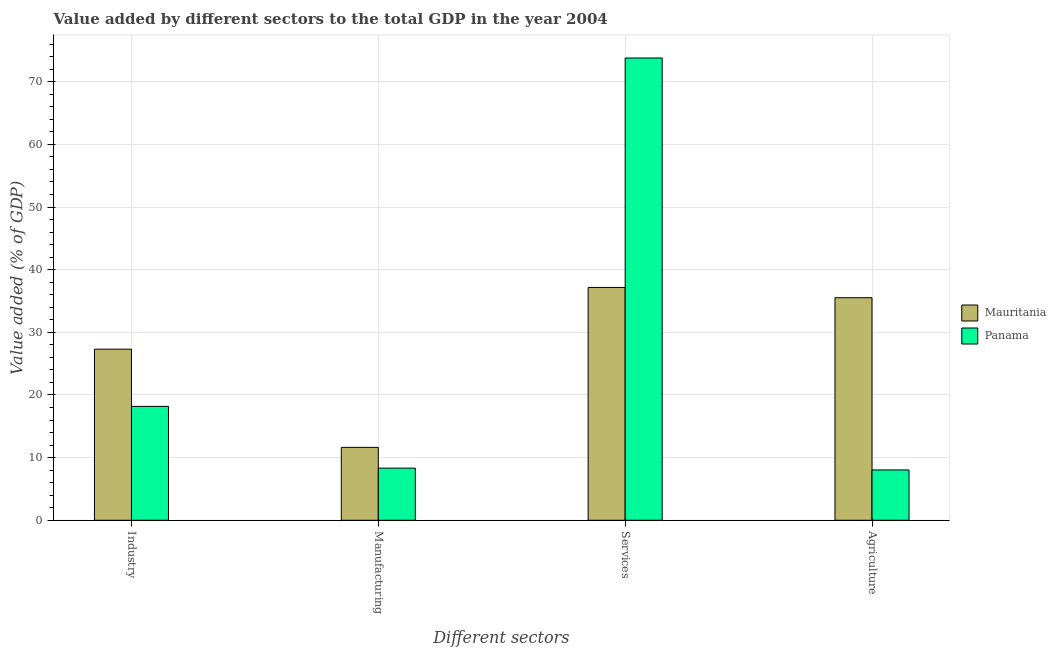How many different coloured bars are there?
Ensure brevity in your answer.  2. Are the number of bars on each tick of the X-axis equal?
Offer a very short reply. Yes. How many bars are there on the 1st tick from the left?
Offer a terse response. 2. What is the label of the 1st group of bars from the left?
Offer a terse response. Industry. What is the value added by services sector in Mauritania?
Your answer should be very brief. 37.16. Across all countries, what is the maximum value added by industrial sector?
Provide a succinct answer. 27.31. Across all countries, what is the minimum value added by agricultural sector?
Give a very brief answer. 8.03. In which country was the value added by services sector maximum?
Keep it short and to the point. Panama. In which country was the value added by manufacturing sector minimum?
Offer a very short reply. Panama. What is the total value added by agricultural sector in the graph?
Make the answer very short. 43.56. What is the difference between the value added by manufacturing sector in Panama and that in Mauritania?
Your response must be concise. -3.31. What is the difference between the value added by services sector in Panama and the value added by agricultural sector in Mauritania?
Your answer should be compact. 38.26. What is the average value added by services sector per country?
Keep it short and to the point. 55.48. What is the difference between the value added by services sector and value added by industrial sector in Mauritania?
Provide a short and direct response. 9.85. In how many countries, is the value added by agricultural sector greater than 38 %?
Offer a terse response. 0. What is the ratio of the value added by manufacturing sector in Panama to that in Mauritania?
Make the answer very short. 0.72. Is the value added by agricultural sector in Panama less than that in Mauritania?
Make the answer very short. Yes. What is the difference between the highest and the second highest value added by agricultural sector?
Ensure brevity in your answer.  27.49. What is the difference between the highest and the lowest value added by manufacturing sector?
Provide a short and direct response. 3.31. In how many countries, is the value added by agricultural sector greater than the average value added by agricultural sector taken over all countries?
Your answer should be very brief. 1. What does the 2nd bar from the left in Manufacturing represents?
Your answer should be very brief. Panama. What does the 1st bar from the right in Industry represents?
Make the answer very short. Panama. How many bars are there?
Ensure brevity in your answer.  8. How many countries are there in the graph?
Keep it short and to the point. 2. Does the graph contain grids?
Your response must be concise. Yes. What is the title of the graph?
Your answer should be very brief. Value added by different sectors to the total GDP in the year 2004. What is the label or title of the X-axis?
Your answer should be very brief. Different sectors. What is the label or title of the Y-axis?
Make the answer very short. Value added (% of GDP). What is the Value added (% of GDP) of Mauritania in Industry?
Keep it short and to the point. 27.31. What is the Value added (% of GDP) of Panama in Industry?
Provide a succinct answer. 18.18. What is the Value added (% of GDP) in Mauritania in Manufacturing?
Give a very brief answer. 11.63. What is the Value added (% of GDP) in Panama in Manufacturing?
Offer a very short reply. 8.32. What is the Value added (% of GDP) of Mauritania in Services?
Keep it short and to the point. 37.16. What is the Value added (% of GDP) in Panama in Services?
Your answer should be compact. 73.79. What is the Value added (% of GDP) of Mauritania in Agriculture?
Make the answer very short. 35.53. What is the Value added (% of GDP) of Panama in Agriculture?
Offer a terse response. 8.03. Across all Different sectors, what is the maximum Value added (% of GDP) in Mauritania?
Keep it short and to the point. 37.16. Across all Different sectors, what is the maximum Value added (% of GDP) in Panama?
Offer a very short reply. 73.79. Across all Different sectors, what is the minimum Value added (% of GDP) in Mauritania?
Keep it short and to the point. 11.63. Across all Different sectors, what is the minimum Value added (% of GDP) in Panama?
Keep it short and to the point. 8.03. What is the total Value added (% of GDP) of Mauritania in the graph?
Give a very brief answer. 111.63. What is the total Value added (% of GDP) of Panama in the graph?
Give a very brief answer. 108.32. What is the difference between the Value added (% of GDP) in Mauritania in Industry and that in Manufacturing?
Ensure brevity in your answer.  15.68. What is the difference between the Value added (% of GDP) in Panama in Industry and that in Manufacturing?
Give a very brief answer. 9.86. What is the difference between the Value added (% of GDP) in Mauritania in Industry and that in Services?
Keep it short and to the point. -9.85. What is the difference between the Value added (% of GDP) in Panama in Industry and that in Services?
Give a very brief answer. -55.61. What is the difference between the Value added (% of GDP) in Mauritania in Industry and that in Agriculture?
Provide a short and direct response. -8.21. What is the difference between the Value added (% of GDP) of Panama in Industry and that in Agriculture?
Your response must be concise. 10.15. What is the difference between the Value added (% of GDP) of Mauritania in Manufacturing and that in Services?
Give a very brief answer. -25.53. What is the difference between the Value added (% of GDP) of Panama in Manufacturing and that in Services?
Your response must be concise. -65.47. What is the difference between the Value added (% of GDP) in Mauritania in Manufacturing and that in Agriculture?
Your answer should be very brief. -23.89. What is the difference between the Value added (% of GDP) of Panama in Manufacturing and that in Agriculture?
Provide a short and direct response. 0.29. What is the difference between the Value added (% of GDP) in Mauritania in Services and that in Agriculture?
Your response must be concise. 1.64. What is the difference between the Value added (% of GDP) of Panama in Services and that in Agriculture?
Offer a very short reply. 65.76. What is the difference between the Value added (% of GDP) in Mauritania in Industry and the Value added (% of GDP) in Panama in Manufacturing?
Provide a succinct answer. 18.99. What is the difference between the Value added (% of GDP) in Mauritania in Industry and the Value added (% of GDP) in Panama in Services?
Your answer should be compact. -46.48. What is the difference between the Value added (% of GDP) of Mauritania in Industry and the Value added (% of GDP) of Panama in Agriculture?
Your response must be concise. 19.28. What is the difference between the Value added (% of GDP) in Mauritania in Manufacturing and the Value added (% of GDP) in Panama in Services?
Your response must be concise. -62.16. What is the difference between the Value added (% of GDP) of Mauritania in Manufacturing and the Value added (% of GDP) of Panama in Agriculture?
Keep it short and to the point. 3.6. What is the difference between the Value added (% of GDP) in Mauritania in Services and the Value added (% of GDP) in Panama in Agriculture?
Offer a terse response. 29.13. What is the average Value added (% of GDP) of Mauritania per Different sectors?
Your answer should be compact. 27.91. What is the average Value added (% of GDP) of Panama per Different sectors?
Keep it short and to the point. 27.08. What is the difference between the Value added (% of GDP) of Mauritania and Value added (% of GDP) of Panama in Industry?
Offer a terse response. 9.13. What is the difference between the Value added (% of GDP) of Mauritania and Value added (% of GDP) of Panama in Manufacturing?
Your answer should be very brief. 3.31. What is the difference between the Value added (% of GDP) in Mauritania and Value added (% of GDP) in Panama in Services?
Your response must be concise. -36.62. What is the difference between the Value added (% of GDP) in Mauritania and Value added (% of GDP) in Panama in Agriculture?
Offer a terse response. 27.49. What is the ratio of the Value added (% of GDP) in Mauritania in Industry to that in Manufacturing?
Ensure brevity in your answer.  2.35. What is the ratio of the Value added (% of GDP) in Panama in Industry to that in Manufacturing?
Your answer should be compact. 2.18. What is the ratio of the Value added (% of GDP) of Mauritania in Industry to that in Services?
Make the answer very short. 0.73. What is the ratio of the Value added (% of GDP) of Panama in Industry to that in Services?
Your response must be concise. 0.25. What is the ratio of the Value added (% of GDP) of Mauritania in Industry to that in Agriculture?
Provide a succinct answer. 0.77. What is the ratio of the Value added (% of GDP) in Panama in Industry to that in Agriculture?
Provide a short and direct response. 2.26. What is the ratio of the Value added (% of GDP) in Mauritania in Manufacturing to that in Services?
Provide a succinct answer. 0.31. What is the ratio of the Value added (% of GDP) in Panama in Manufacturing to that in Services?
Keep it short and to the point. 0.11. What is the ratio of the Value added (% of GDP) in Mauritania in Manufacturing to that in Agriculture?
Offer a very short reply. 0.33. What is the ratio of the Value added (% of GDP) of Panama in Manufacturing to that in Agriculture?
Give a very brief answer. 1.04. What is the ratio of the Value added (% of GDP) of Mauritania in Services to that in Agriculture?
Offer a terse response. 1.05. What is the ratio of the Value added (% of GDP) of Panama in Services to that in Agriculture?
Provide a succinct answer. 9.19. What is the difference between the highest and the second highest Value added (% of GDP) of Mauritania?
Your answer should be compact. 1.64. What is the difference between the highest and the second highest Value added (% of GDP) of Panama?
Give a very brief answer. 55.61. What is the difference between the highest and the lowest Value added (% of GDP) of Mauritania?
Give a very brief answer. 25.53. What is the difference between the highest and the lowest Value added (% of GDP) in Panama?
Your answer should be very brief. 65.76. 